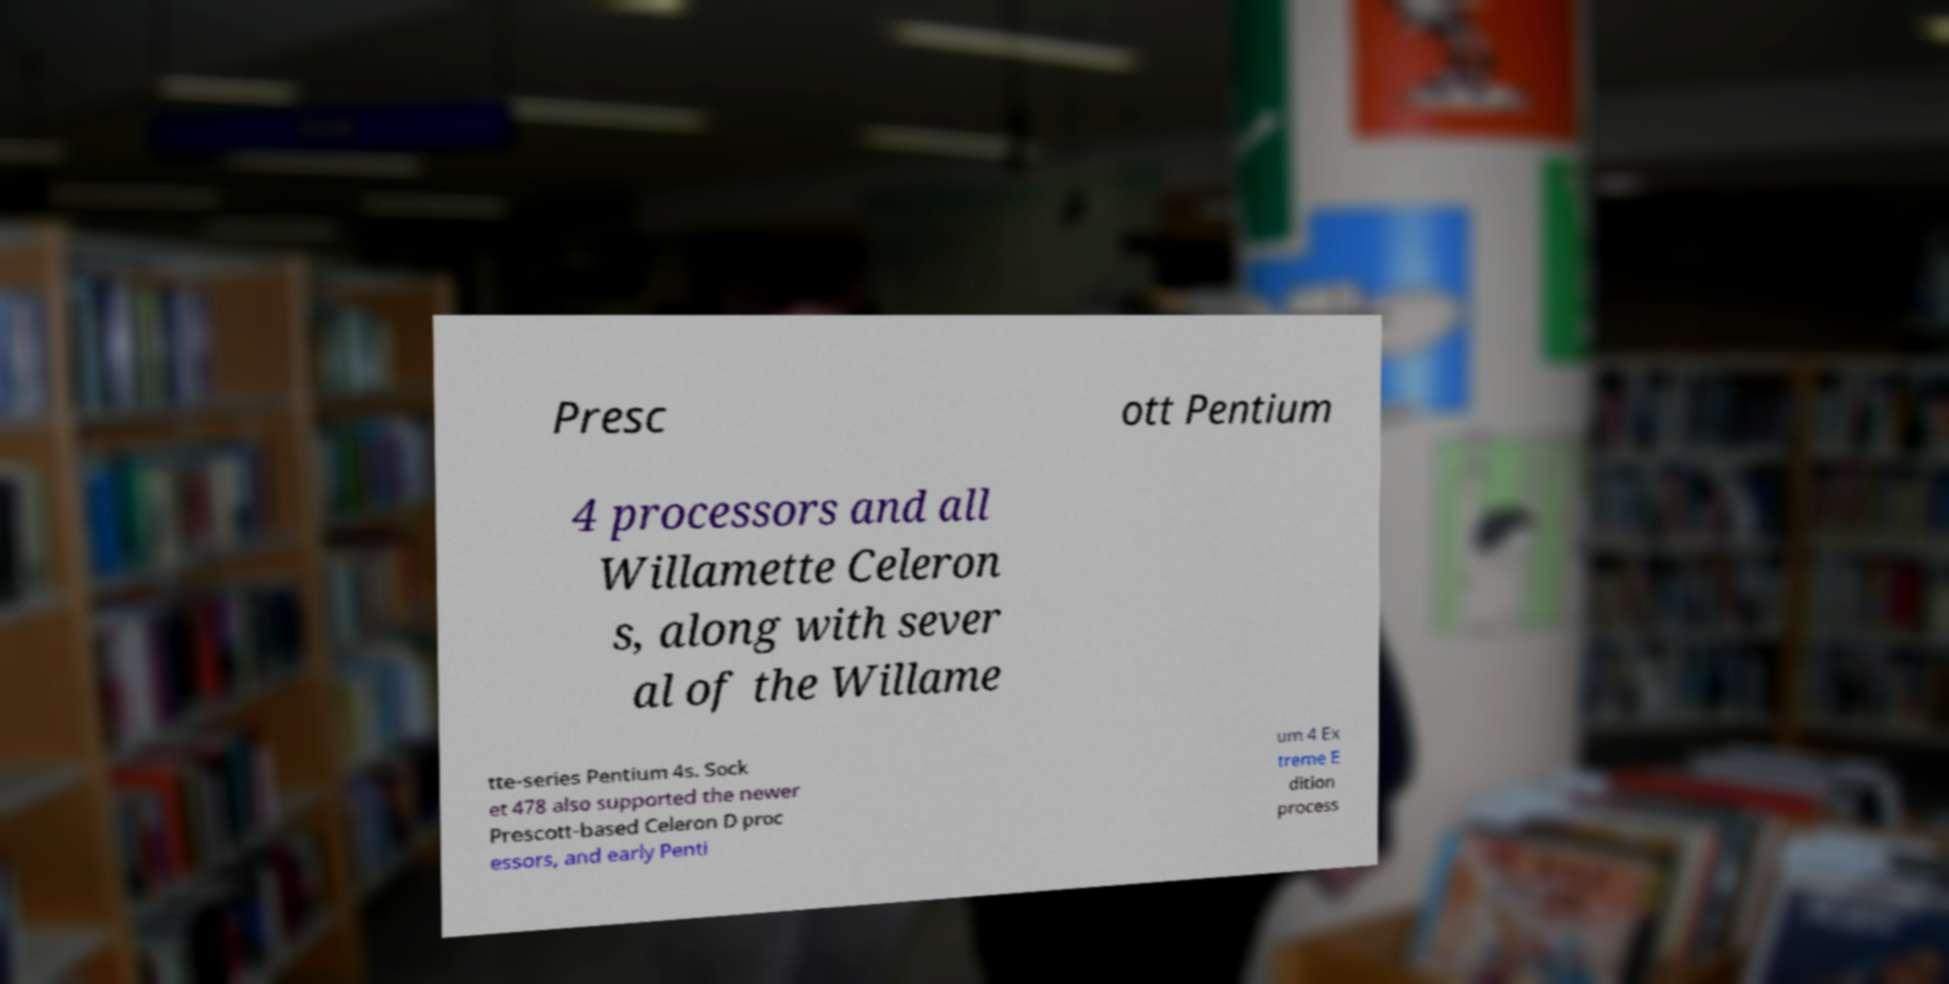What messages or text are displayed in this image? I need them in a readable, typed format. Presc ott Pentium 4 processors and all Willamette Celeron s, along with sever al of the Willame tte-series Pentium 4s. Sock et 478 also supported the newer Prescott-based Celeron D proc essors, and early Penti um 4 Ex treme E dition process 